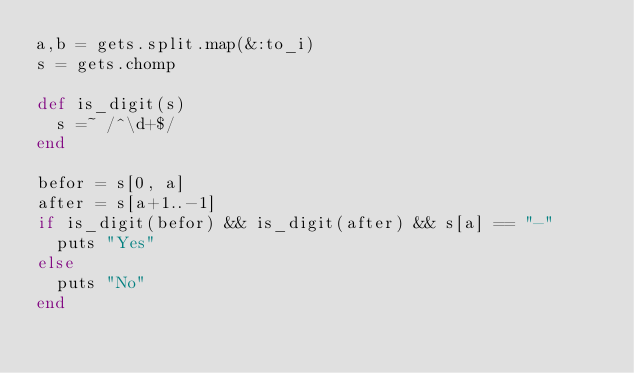<code> <loc_0><loc_0><loc_500><loc_500><_Ruby_>a,b = gets.split.map(&:to_i)
s = gets.chomp

def is_digit(s)
  s =~ /^\d+$/
end

befor = s[0, a]
after = s[a+1..-1]
if is_digit(befor) && is_digit(after) && s[a] == "-"
  puts "Yes"
else
  puts "No"
end
</code> 